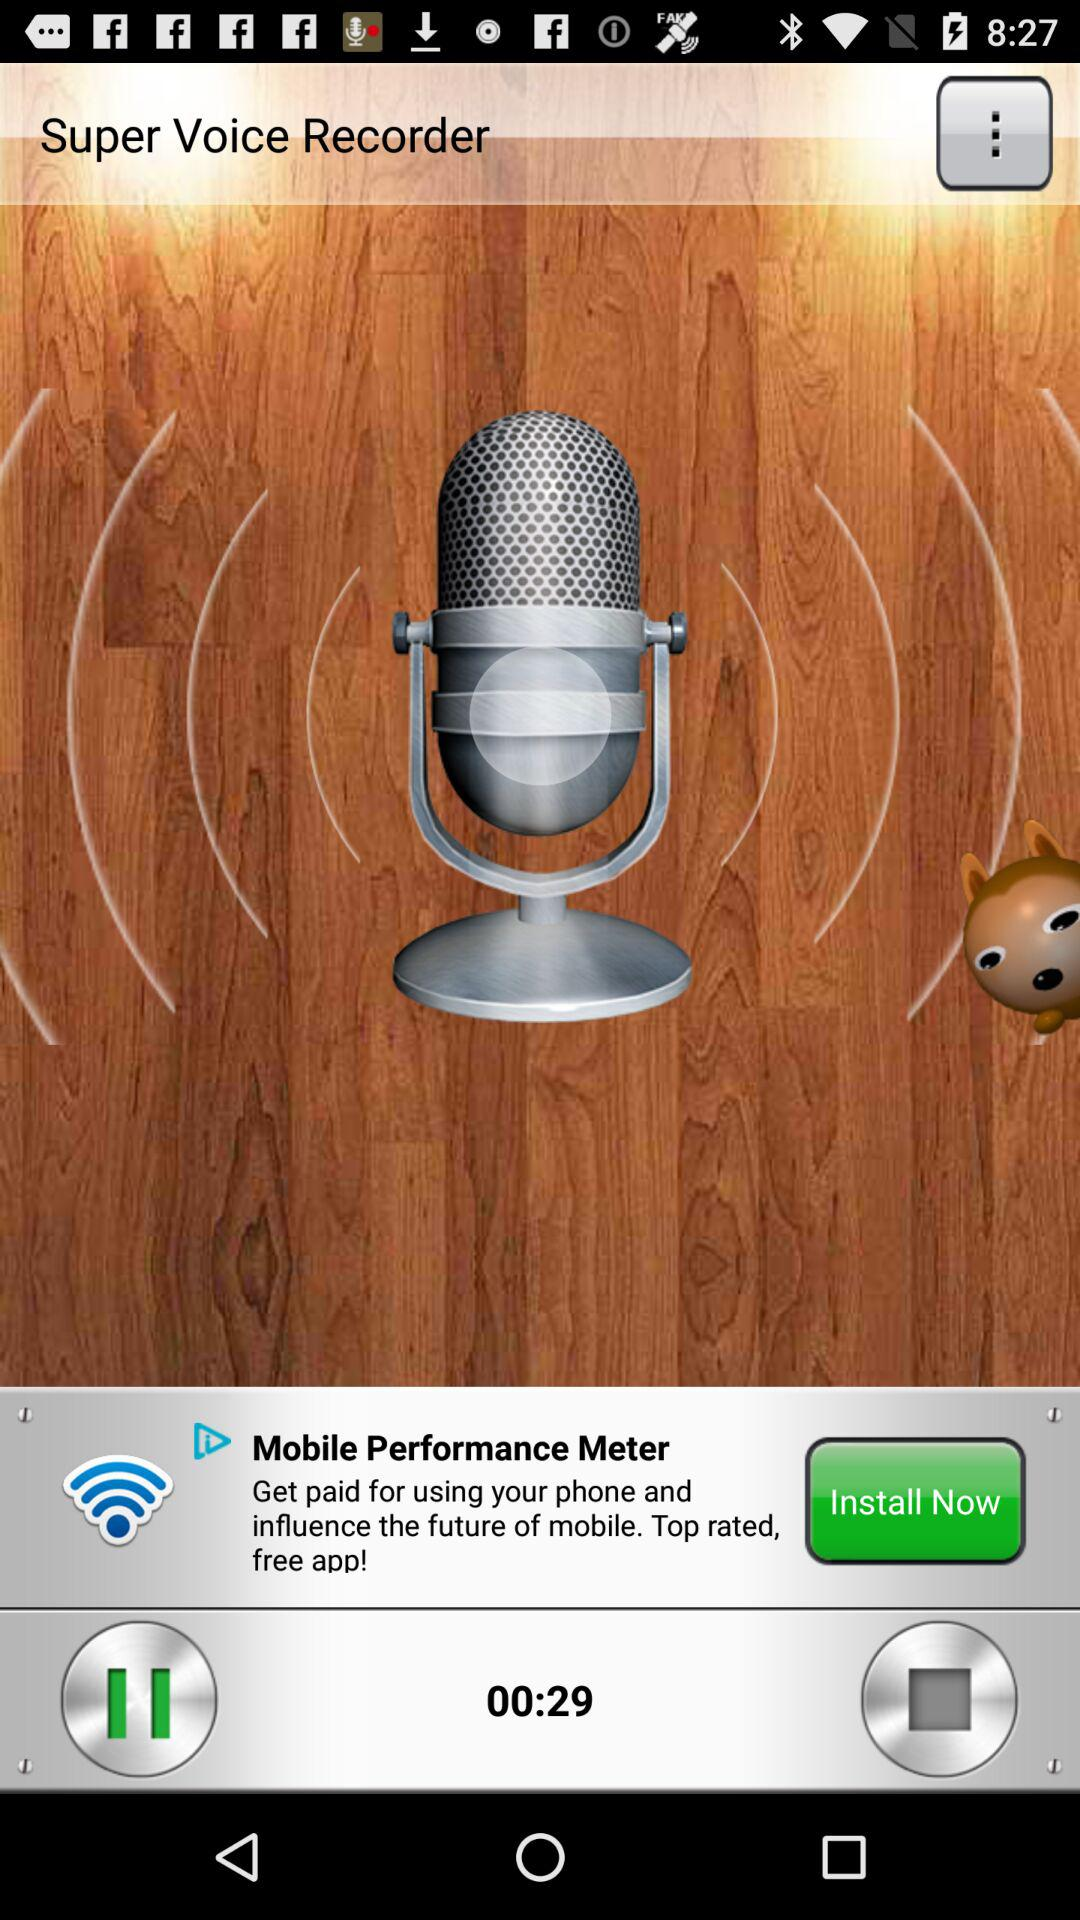How long is the recording?
Answer the question using a single word or phrase. 00:29 